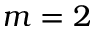Convert formula to latex. <formula><loc_0><loc_0><loc_500><loc_500>m = 2</formula> 